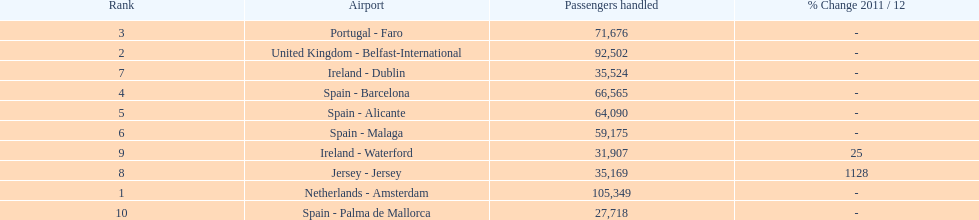How many airports in spain are among the 10 busiest routes to and from london southend airport in 2012? 4. 